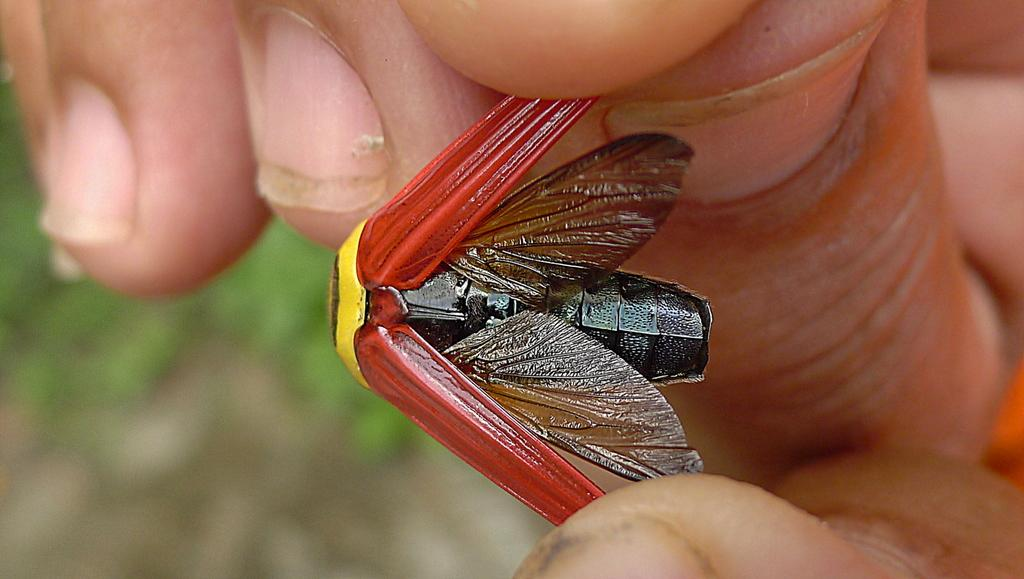What is the main subject of the image? There is a person in the image. What is the person holding in the image? The person is holding an insect. Can you describe the colors of the insect? The insect has brown, black, red, and yellow colors. What type of glass is being used as a guide for the insect in the image? There is no glass or guide present in the image; the person is simply holding the insect. 